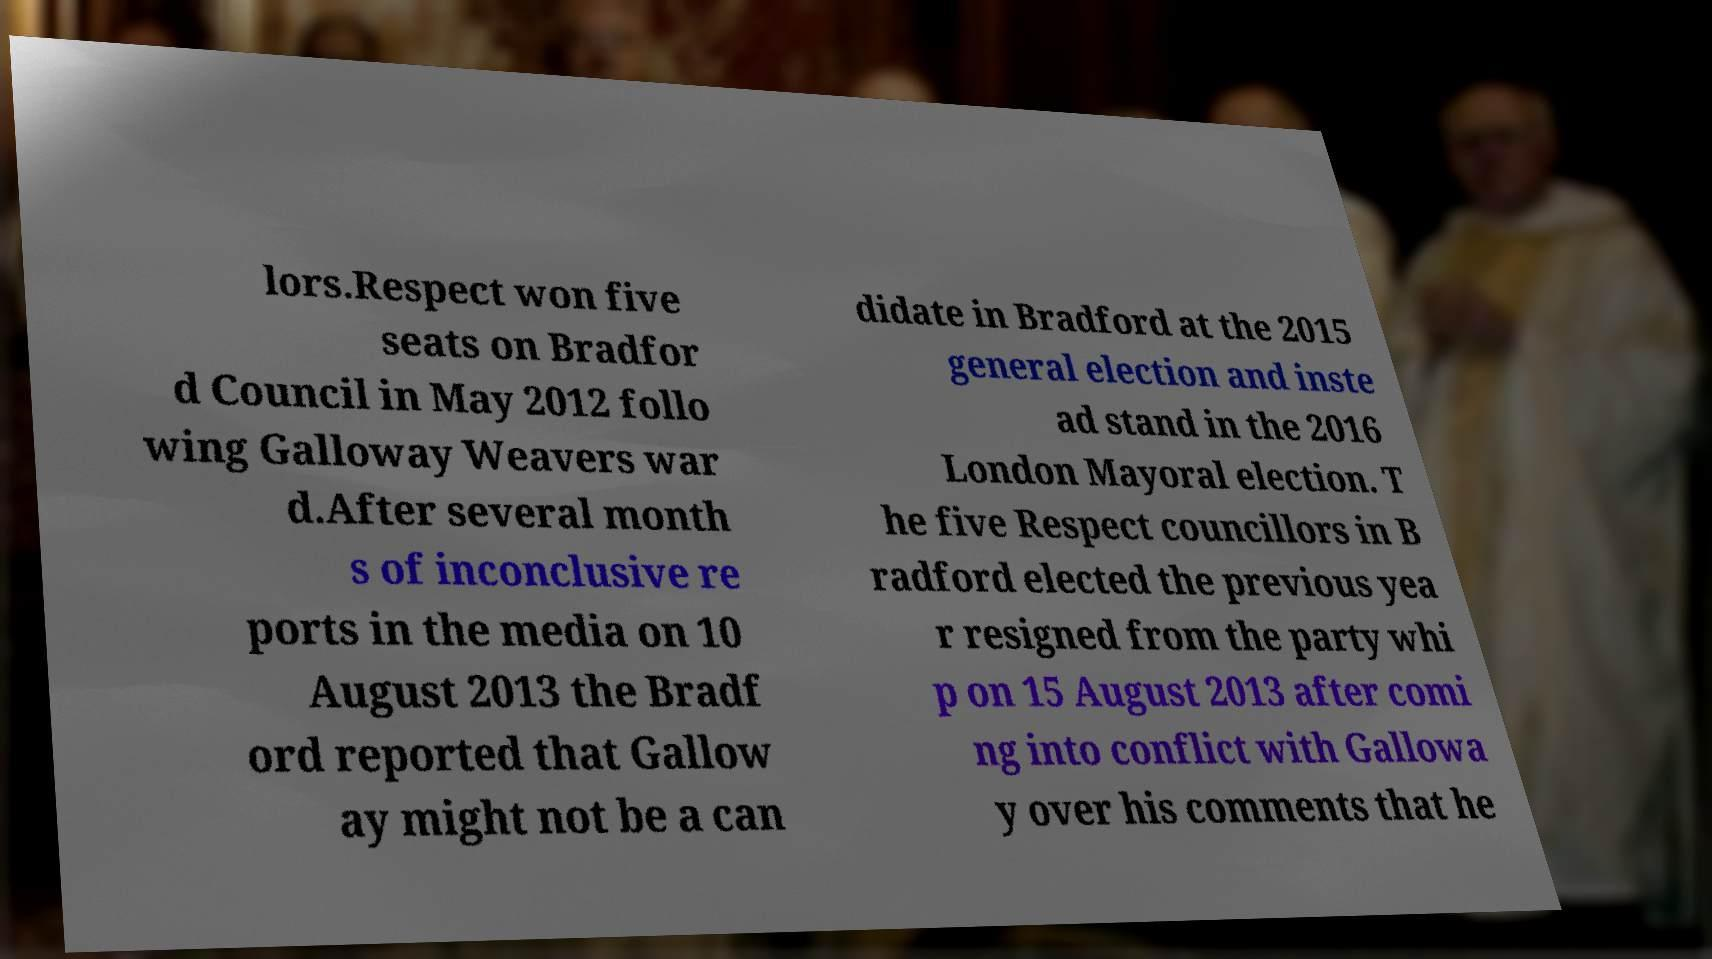What messages or text are displayed in this image? I need them in a readable, typed format. lors.Respect won five seats on Bradfor d Council in May 2012 follo wing Galloway Weavers war d.After several month s of inconclusive re ports in the media on 10 August 2013 the Bradf ord reported that Gallow ay might not be a can didate in Bradford at the 2015 general election and inste ad stand in the 2016 London Mayoral election. T he five Respect councillors in B radford elected the previous yea r resigned from the party whi p on 15 August 2013 after comi ng into conflict with Gallowa y over his comments that he 